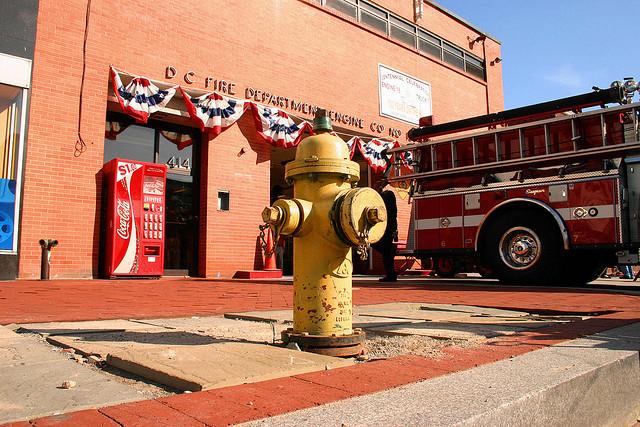Are there any animals in the picture?
Write a very short answer. No. What drink machine is near the building?
Give a very brief answer. Coca cola. What kind of vehicle is in the picture?
Quick response, please. Fire truck. 